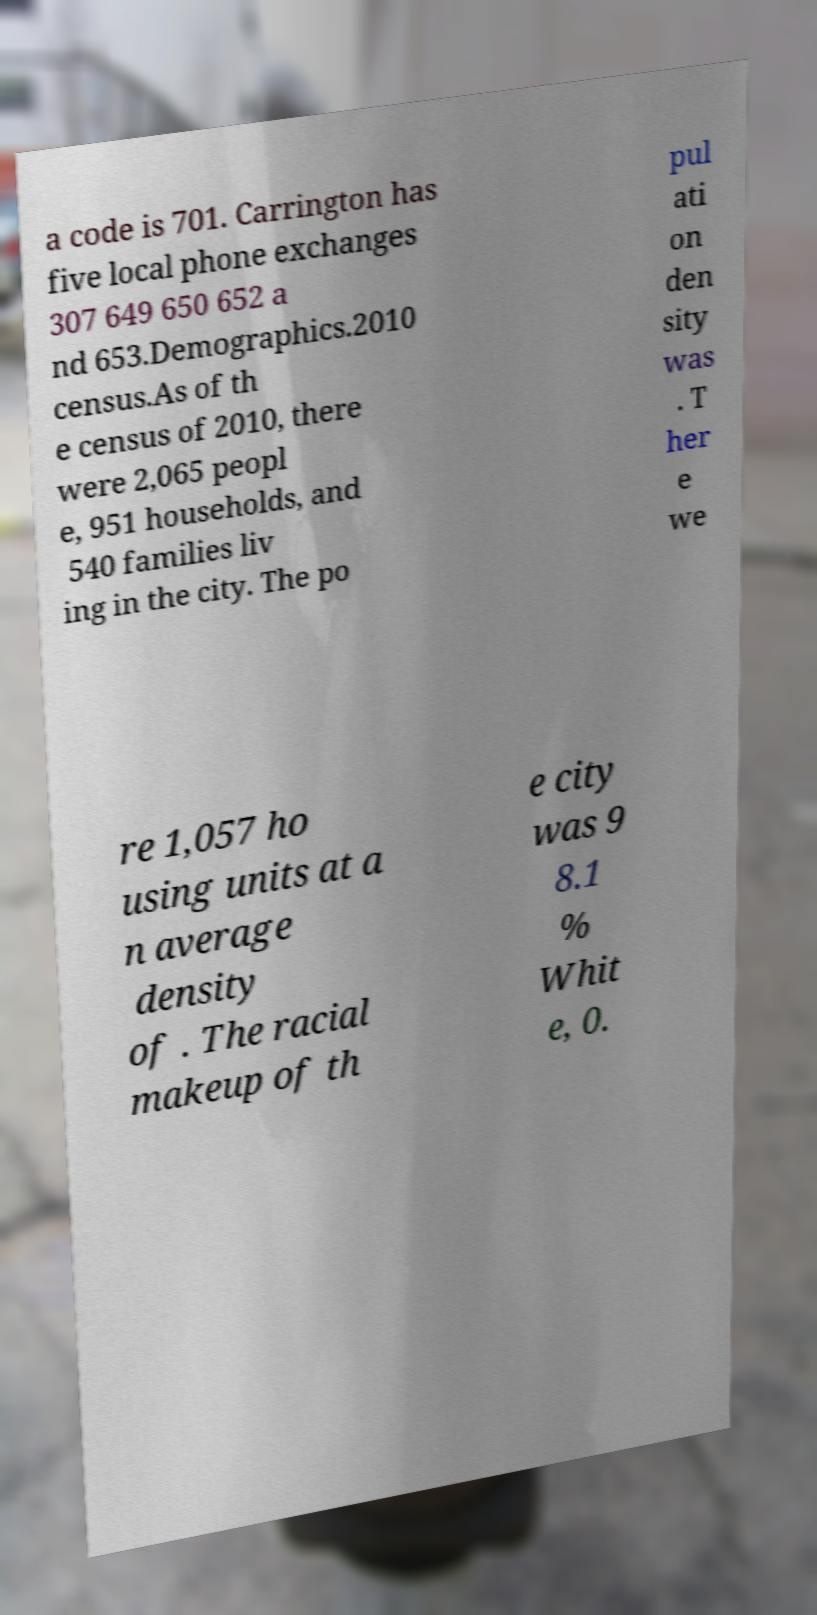Could you extract and type out the text from this image? a code is 701. Carrington has five local phone exchanges 307 649 650 652 a nd 653.Demographics.2010 census.As of th e census of 2010, there were 2,065 peopl e, 951 households, and 540 families liv ing in the city. The po pul ati on den sity was . T her e we re 1,057 ho using units at a n average density of . The racial makeup of th e city was 9 8.1 % Whit e, 0. 